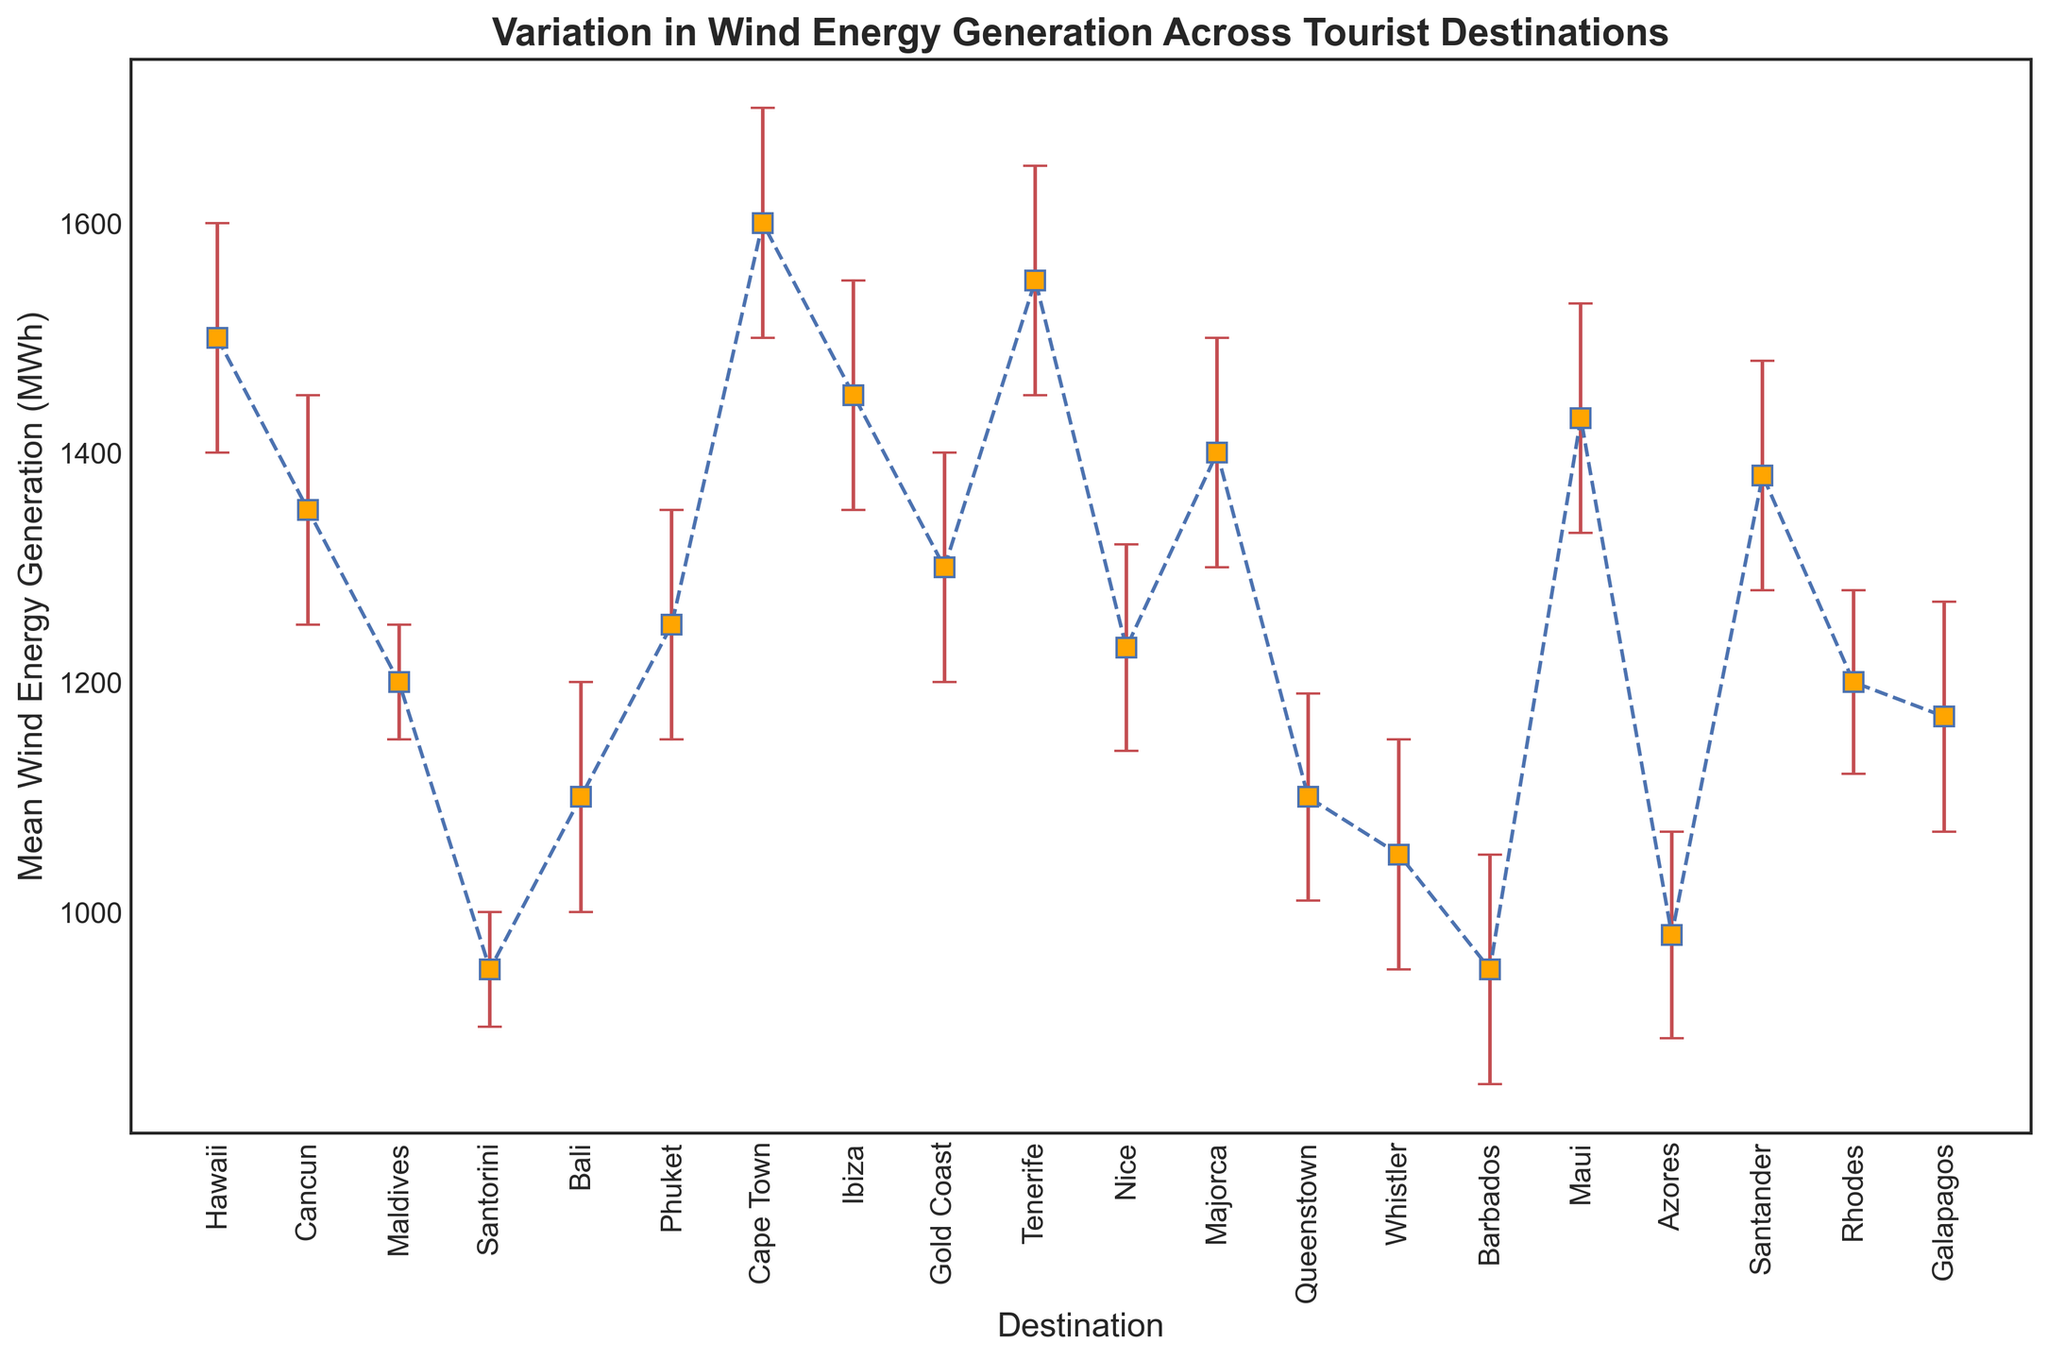Which destination has the highest mean wind energy generation? The highest mean wind energy generation is marked by the tallest point in the plot with its respective error bar. Cape Town has the highest mean value of wind energy generation with 1600 MWh.
Answer: Cape Town Which destination has the largest confidence interval range for wind energy generation? The largest confidence interval range can be identified by the error bars extending furthest from the point. Maui’s confidence interval is from 1330 MWh to 1530 MWh, which is a range of 200 MWh.
Answer: Maui How does the mean wind energy generation in Hawaii compare to Santorini? By comparing their respective points on the plot, Hawaii has a mean wind energy generation of 1500 MWh, whereas Santorini has 950 MWh. The difference is 550 MWh.
Answer: Hawaii generates 550 MWh more Which destination has the lowest upper confidence interval? The upper confidence interval is the upper bound of the error bars. Barbados has the lowest upper confidence interval at 1050 MWh.
Answer: Barbados What is the range of wind energy generation for Tenerife? The range is calculated from the lower to the upper confidence interval, which for Tenerife is 1450 MWh to 1650 MWh. Therefore, the range is 200 MWh.
Answer: 200 MWh Which destination means fall entirely within the confidence interval of Cape Town? Cape Town's confidence interval ranges from 1500 to 1700 MWh. Checking each mean: Tenerife (1550), Hawaii (1500), and Maui (1430) are within this range, but only Tenerife and Hawaii fall entirely within it.
Answer: Tenerife, Hawaii What is the average mean wind energy generation for the destinations with a mean over 1400 MWh? Destinations with means over 1400 MWh are Hawaii (1500), Cape Town (1600), Ibiza (1450), Tenerife (1550), Majorca (1400), Santander (1380), Maui (1430). The average is calculated as (1500 + 1600 + 1450 + 1550 + 1400 + 1430) / 6.
Answer: 1488.33 MWh Which destination has the smallest margin of error in its confidence interval? The smallest margin of error is the narrowest error bar. Maldives has the smallest margin, with a range of only 50 MWh (1150 to 1200 MWh).
Answer: Maldives How do the mean values of Nice and Rhodes compare? Which is higher? By comparing their respective points, Nice has a mean wind energy generation of 1230 MWh, while Rhodes has 1200 MWh. Nice is higher by 30 MWh.
Answer: Nice How many destinations have a mean wind energy generation below 1200 MWh? By identifying the points below 1200 MWh on the plot: Santorini (950), Bali (1100), Queenstown (1100), Whistler (1050), Barbados (950), Azores (980), Galapagos (1170), Rhodes (1200), Nice (1230), Maldives (1200). 8 destinations have mean values below 1200 MWh.
Answer: 8 